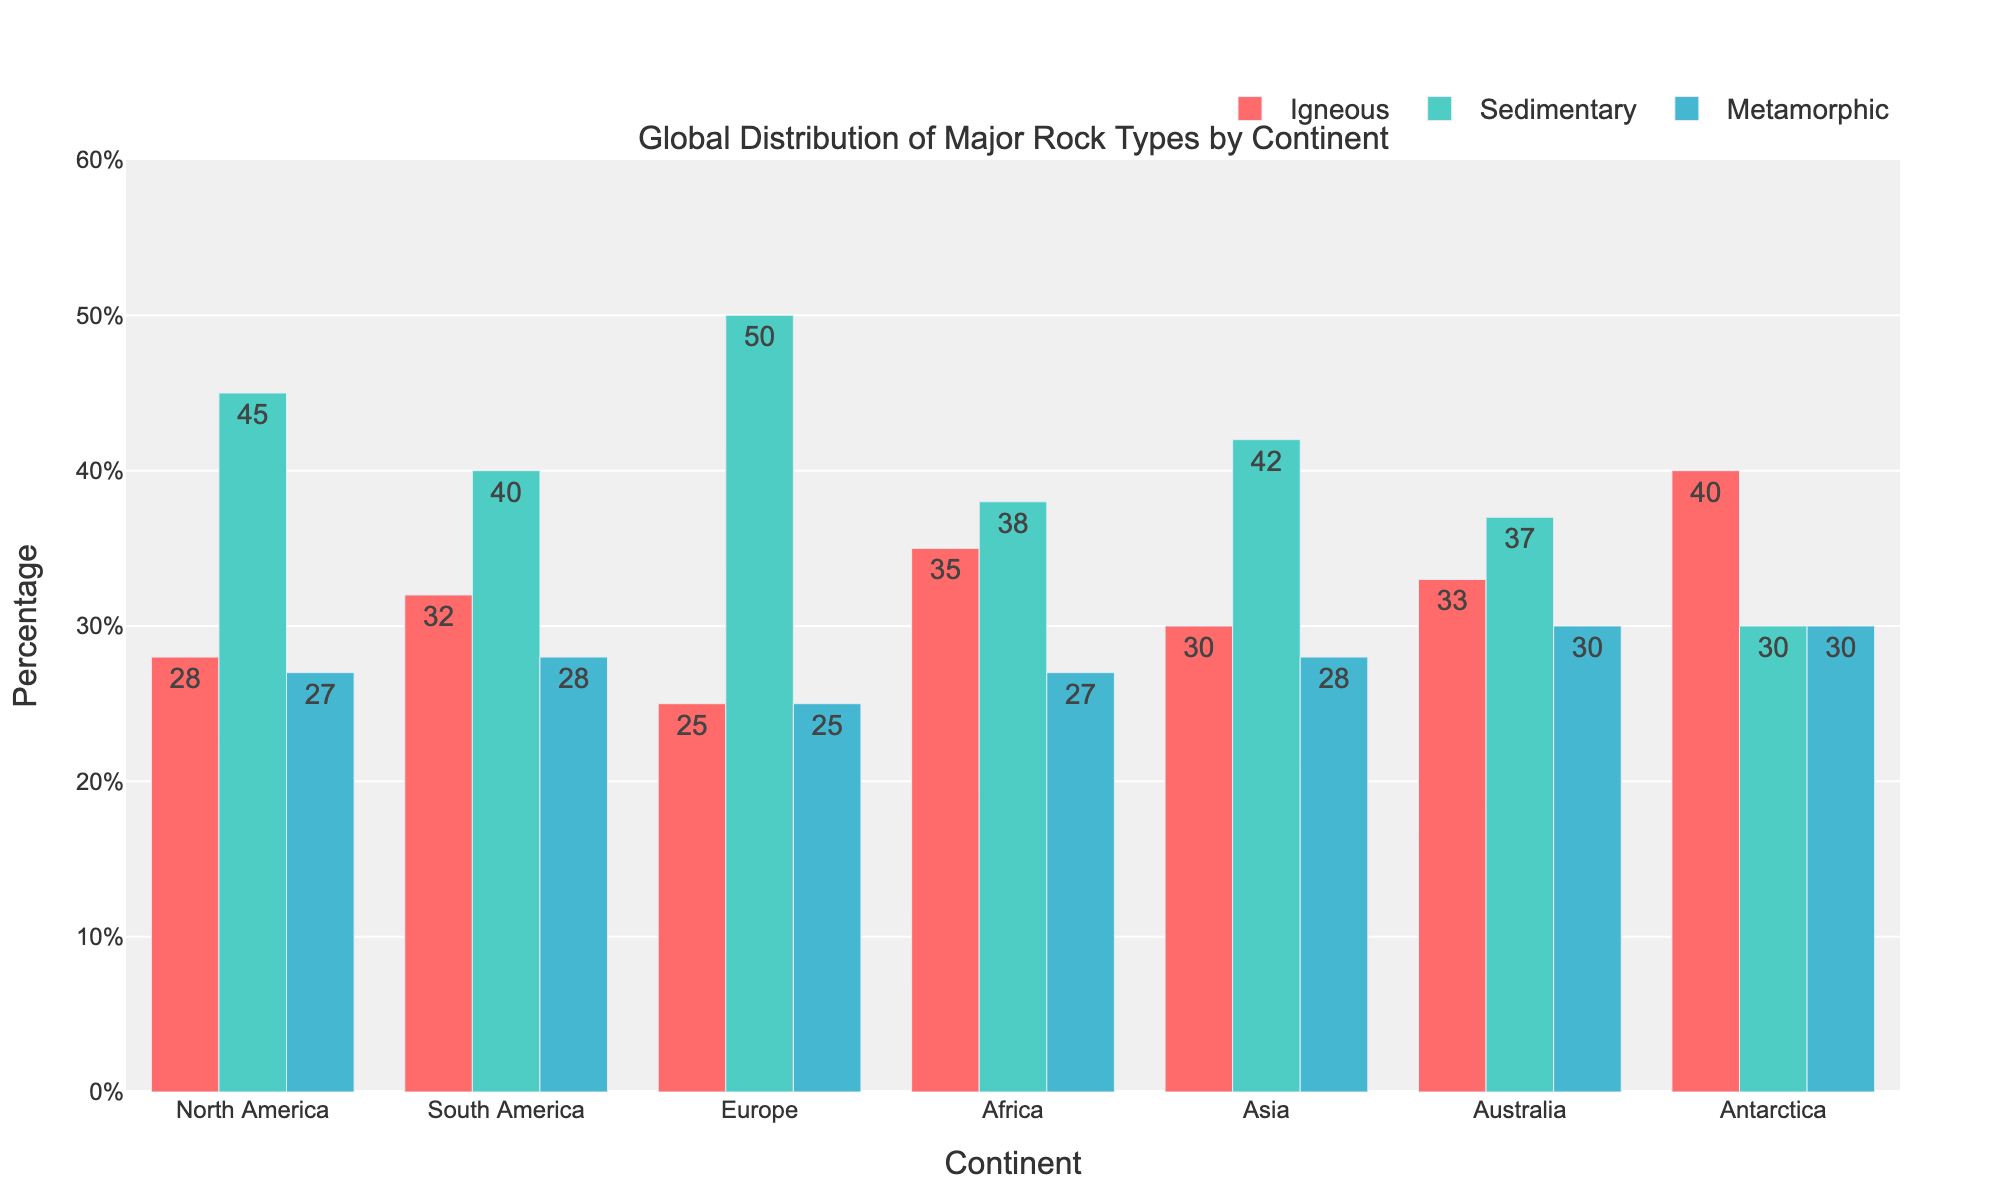Which continent has the highest percentage of igneous rocks? By observing the heights of the bars associated with igneous rocks for each continent, the tallest bar corresponds to Antarctica.
Answer: Antarctica How does the percentage of sedimentary rocks in Europe compare to Asia? Look at the heights of the bars representing sedimentary rocks for Europe and Asia. The bar for Europe is taller, indicating a higher percentage. Specifically, Europe has 50% and Asia has 42%.
Answer: Europe has more Which continent has an equal distribution of metamorphic rocks to another continent, and what is the percentage? Compare the heights of the bars representing metamorphic rocks. Antarctica and Australia both have bars of the same height. The percentage is 30%.
Answer: Antarctica and Australia, 30% What is the total percentage of igneous and sedimentary rocks in South America? Identify the heights of the bars for igneous and sedimentary rocks in South America and sum them. Igneous is 32% and sedimentary is 40%. Thus, 32% + 40% = 72%.
Answer: 72% Which two continents have the closest percentages of igneous rocks? Compare the heights of the bars associated with igneous rocks for every continent. North America has 28% and Asia has 30%, which are closest to each other.
Answer: North America and Asia What is the difference in the percentage of metamorphic rocks between Africa and Antarctica? Identify the heights of the bars representing metamorphic rocks for Africa and Antarctica, then find the difference. Africa has 27% metamorphic rocks and Antarctica has 30%, so the difference is 30% - 27% = 3%.
Answer: 3% What percentage of North America's rock types are sedimentary or metamorphic? Identify the percentages for sedimentary and metamorphic rocks in North America and sum them. Sedimentary is 45% and metamorphic is 27%. Thus, 45% + 27% = 72%.
Answer: 72% Between which continents is the difference in sedimentary rock percentages the largest? Compare the heights of the bars representing sedimentary rocks for all continents. The biggest difference is between Europe (50%) and Antarctica (30%), making a difference of 20%.
Answer: Europe and Antarctica Which continent has the smallest percentage of sedimentary rocks? Identify the smallest bar height for sedimentary rocks among all continents. Antarctica has the smallest bar, indicating 30%.
Answer: Antarctica What is the average percentage of igneous rocks across all continents? Sum the percentages of igneous rocks for all continents and divide by the number of continents. (28% + 32% + 25% + 35% + 30% + 33% + 40%) / 7 = 31.86%.
Answer: 31.86% 